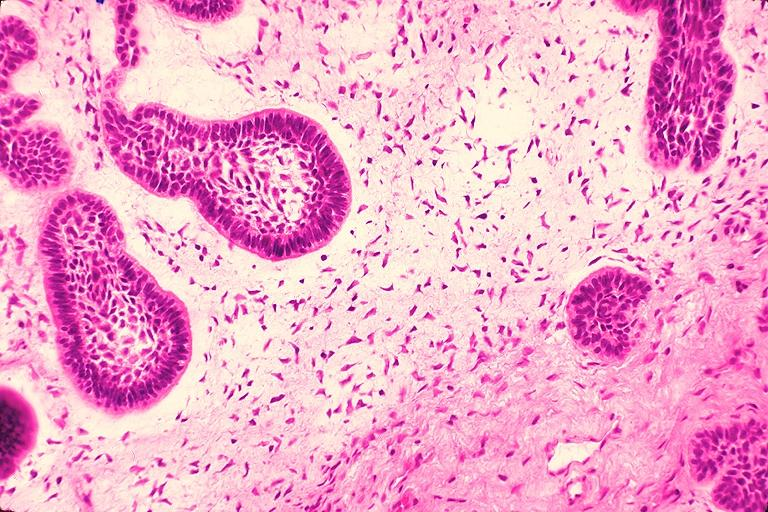what does this image show?
Answer the question using a single word or phrase. Ameloblastic fibroma 